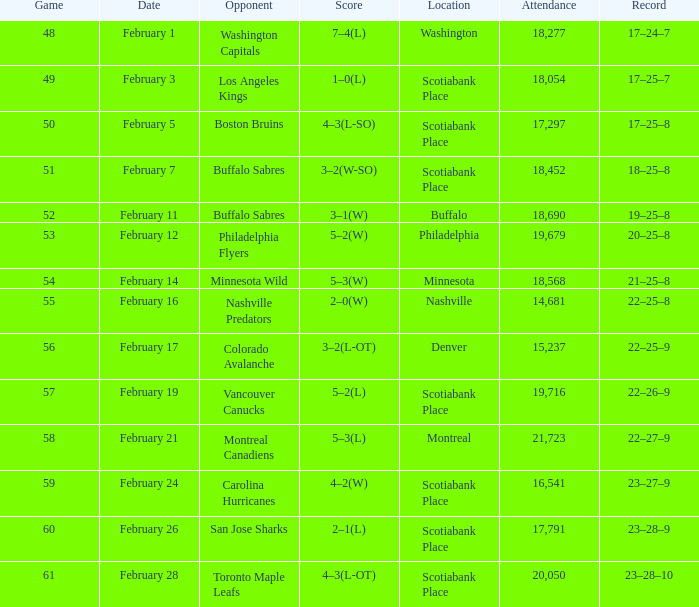What typical game occurred on february 24 with a spectator count below 16,541? None. 